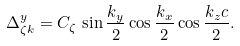Convert formula to latex. <formula><loc_0><loc_0><loc_500><loc_500>\Delta ^ { y } _ { \zeta k } = C _ { \zeta } \, \sin \frac { k _ { y } } { 2 } \cos \frac { k _ { x } } { 2 } \cos \frac { k _ { z } c } { 2 } .</formula> 